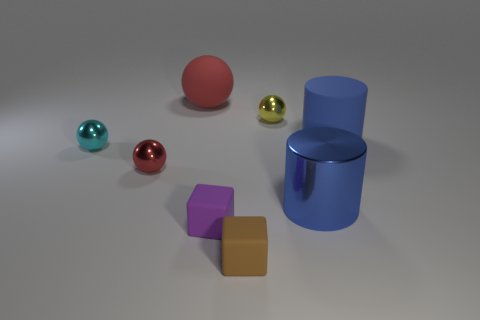Add 1 yellow metal balls. How many objects exist? 9 Subtract all tiny cyan spheres. How many spheres are left? 3 Subtract all blocks. How many objects are left? 6 Subtract all cyan balls. How many balls are left? 3 Subtract all gray cubes. How many cyan spheres are left? 1 Subtract all green rubber things. Subtract all tiny red metallic objects. How many objects are left? 7 Add 5 cyan spheres. How many cyan spheres are left? 6 Add 3 tiny cyan metallic spheres. How many tiny cyan metallic spheres exist? 4 Subtract 0 cyan cylinders. How many objects are left? 8 Subtract all red cylinders. Subtract all green balls. How many cylinders are left? 2 